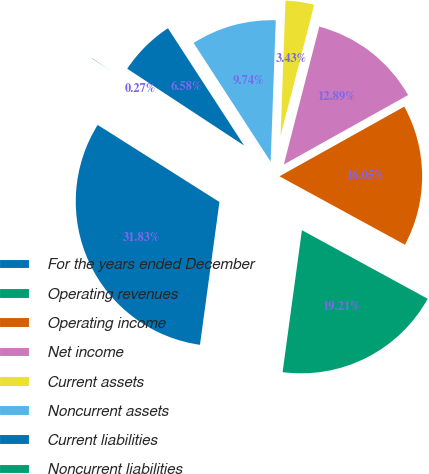Convert chart. <chart><loc_0><loc_0><loc_500><loc_500><pie_chart><fcel>For the years ended December<fcel>Operating revenues<fcel>Operating income<fcel>Net income<fcel>Current assets<fcel>Noncurrent assets<fcel>Current liabilities<fcel>Noncurrent liabilities<nl><fcel>31.83%<fcel>19.21%<fcel>16.05%<fcel>12.89%<fcel>3.43%<fcel>9.74%<fcel>6.58%<fcel>0.27%<nl></chart> 